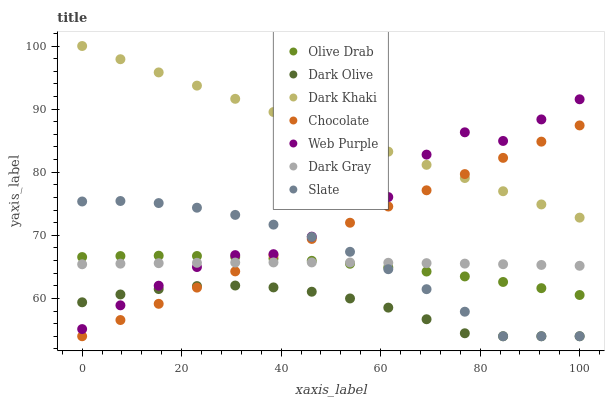Does Dark Olive have the minimum area under the curve?
Answer yes or no. Yes. Does Dark Khaki have the maximum area under the curve?
Answer yes or no. Yes. Does Slate have the minimum area under the curve?
Answer yes or no. No. Does Slate have the maximum area under the curve?
Answer yes or no. No. Is Chocolate the smoothest?
Answer yes or no. Yes. Is Web Purple the roughest?
Answer yes or no. Yes. Is Slate the smoothest?
Answer yes or no. No. Is Slate the roughest?
Answer yes or no. No. Does Slate have the lowest value?
Answer yes or no. Yes. Does Dark Khaki have the lowest value?
Answer yes or no. No. Does Dark Khaki have the highest value?
Answer yes or no. Yes. Does Slate have the highest value?
Answer yes or no. No. Is Olive Drab less than Dark Khaki?
Answer yes or no. Yes. Is Dark Khaki greater than Olive Drab?
Answer yes or no. Yes. Does Olive Drab intersect Web Purple?
Answer yes or no. Yes. Is Olive Drab less than Web Purple?
Answer yes or no. No. Is Olive Drab greater than Web Purple?
Answer yes or no. No. Does Olive Drab intersect Dark Khaki?
Answer yes or no. No. 